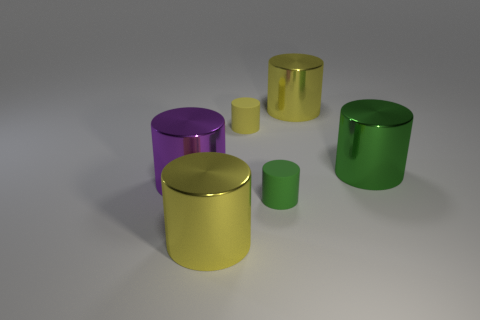Subtract all metallic cylinders. How many cylinders are left? 2 Subtract all purple cubes. How many yellow cylinders are left? 3 Subtract 4 cylinders. How many cylinders are left? 2 Subtract all green cylinders. How many cylinders are left? 4 Add 2 tiny purple metallic cylinders. How many objects exist? 8 Subtract all purple cylinders. Subtract all red cubes. How many cylinders are left? 5 Add 5 green objects. How many green objects exist? 7 Subtract 0 purple blocks. How many objects are left? 6 Subtract all small blue things. Subtract all big purple objects. How many objects are left? 5 Add 4 large purple metal cylinders. How many large purple metal cylinders are left? 5 